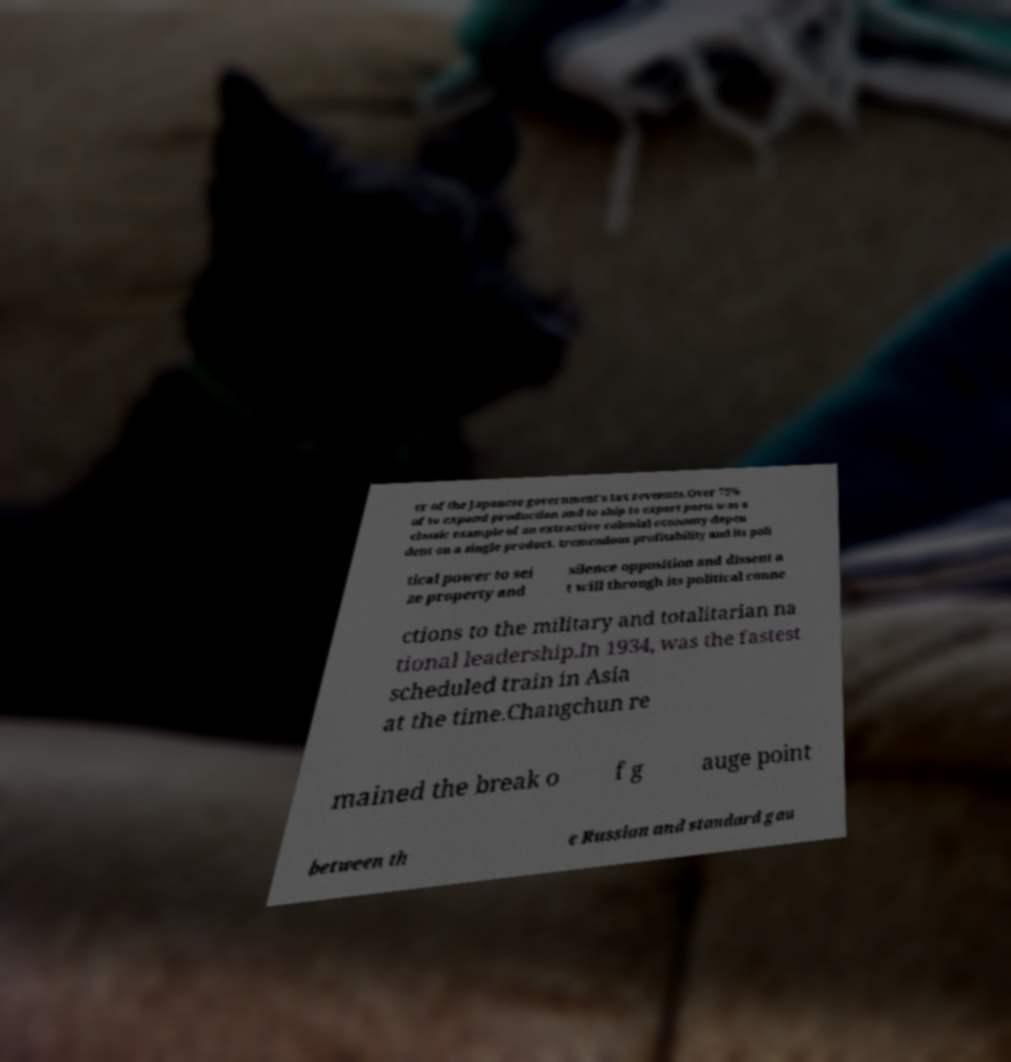I need the written content from this picture converted into text. Can you do that? er of the Japanese government's tax revenues.Over 75% of to expand production and to ship to export ports was a classic example of an extractive colonial economy depen dent on a single product. tremendous profitability and its poli tical power to sei ze property and silence opposition and dissent a t will through its political conne ctions to the military and totalitarian na tional leadership.In 1934, was the fastest scheduled train in Asia at the time.Changchun re mained the break o f g auge point between th e Russian and standard gau 